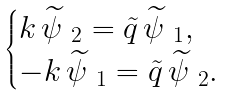<formula> <loc_0><loc_0><loc_500><loc_500>\begin{cases} k \, \widetilde { \psi } _ { \ 2 } = \tilde { q } \, \widetilde { \psi } _ { \ 1 } , \\ - k \, \widetilde { \psi } _ { \ 1 } = \tilde { q } \, \widetilde { \psi } _ { \ 2 } . \end{cases}</formula> 